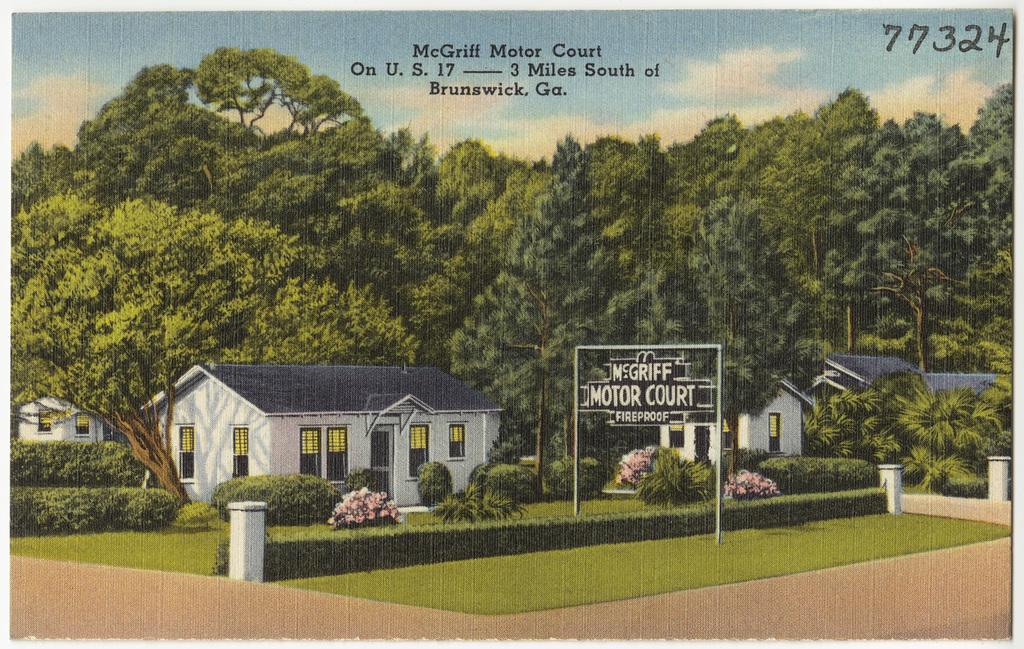Could you give a brief overview of what you see in this image? The image is looking like a depiction. In the foreground there are plants, board, grass and road. In the middle of the picture there are houses, plants and trees. At the top there are clouds. In the sky and there is text also. 